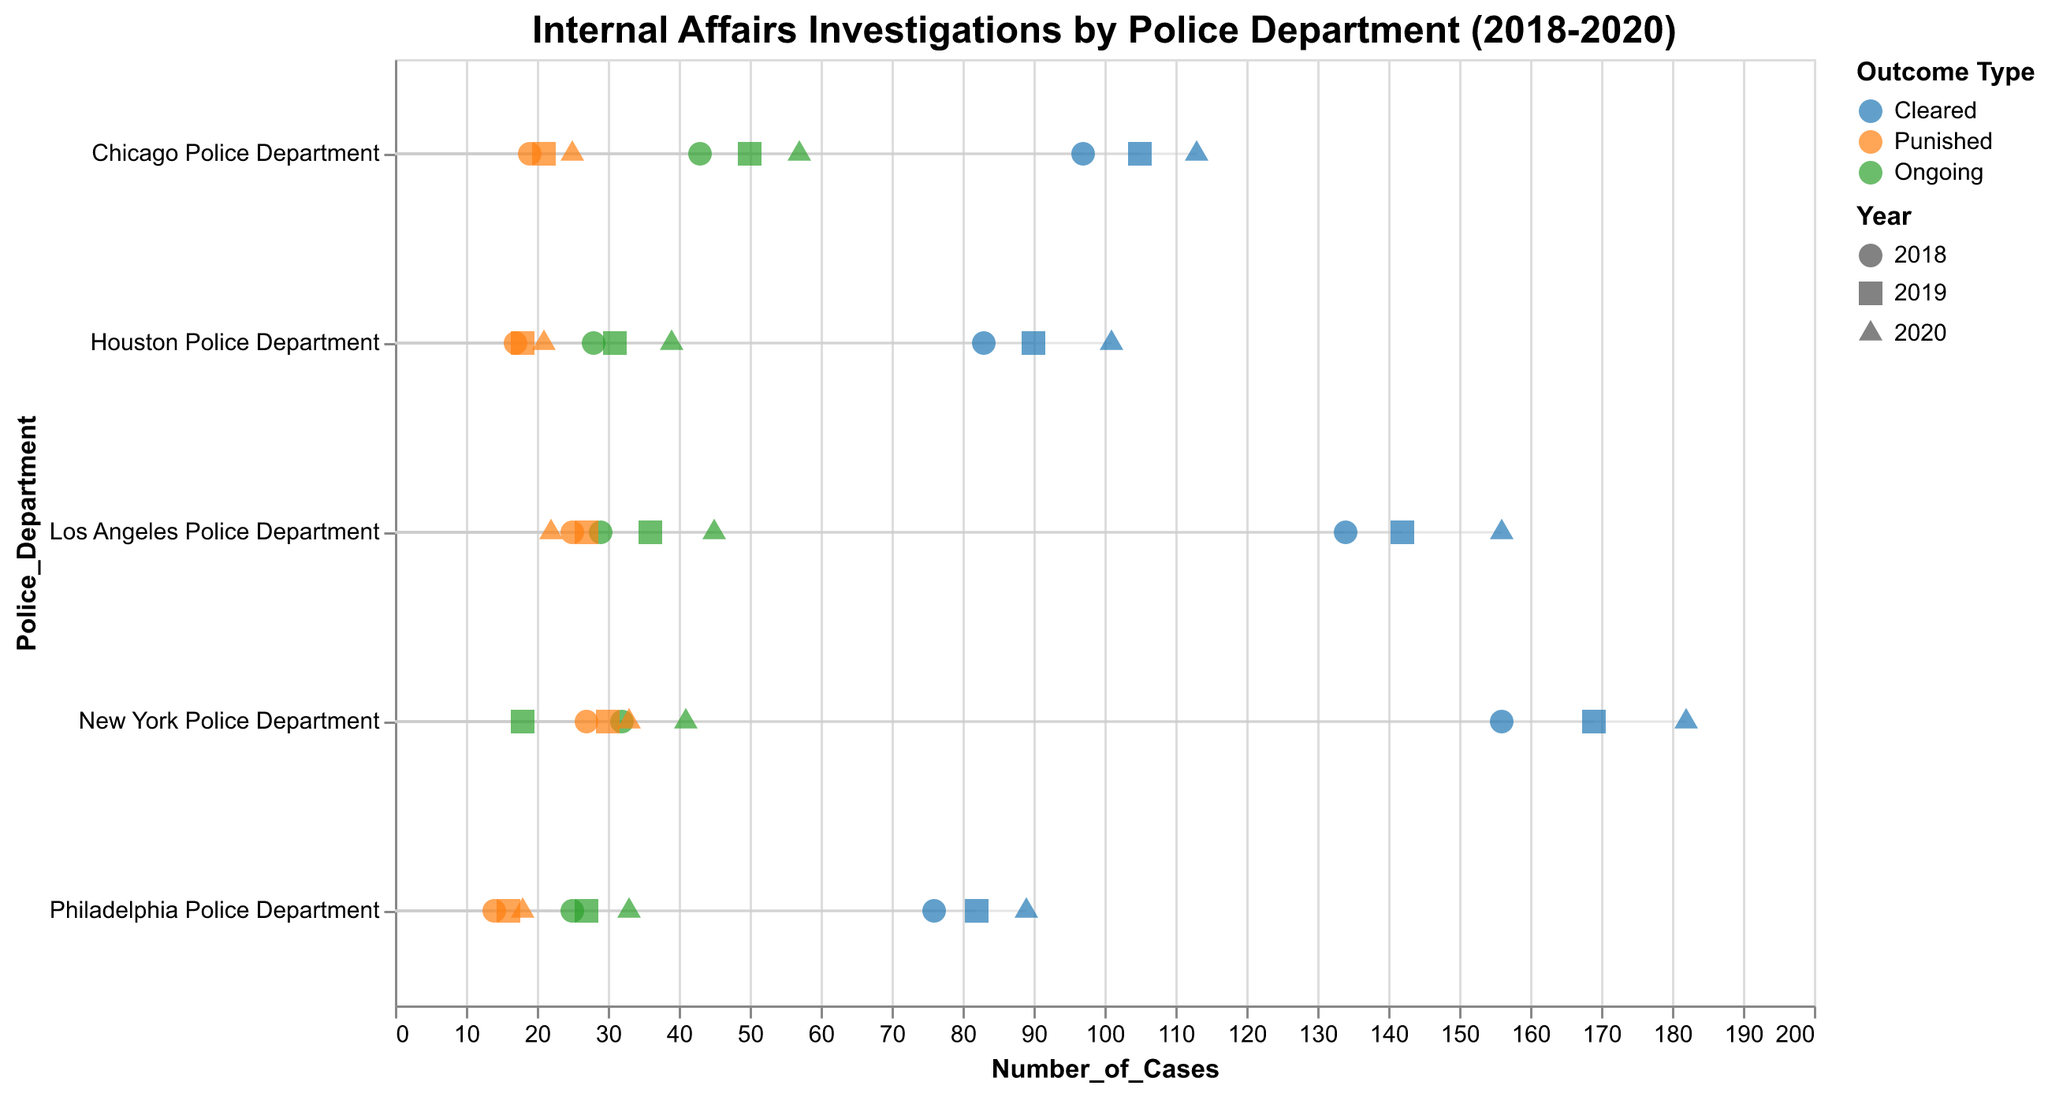Which police department had the highest number of cleared cases in 2020? The highest number of cleared cases in 2020 is represented by the blue triangle with the highest x-value in the 2020 year. The highest value of cleared cases is 182, which belongs to the New York Police Department.
Answer: New York Police Department Which police department had the lowest number of punished cases in 2018? The lowest punished cases in 2018 is represented by the orange circle with the lowest x-value in the 2018 year. The lowest value of punished cases is 14, which belongs to the Philadelphia Police Department.
Answer: Philadelphia Police Department How many ongoing cases were there in the Chicago Police Department across all three years? We need to sum the number of ongoing cases for the Chicago Police Department in 2018, 2019, and 2020. That's 43 + 50 + 57.
Answer: 150 In 2019, did the New York Police Department or the Los Angeles Police Department have more ongoing cases? Compare the number of ongoing cases for both departments in 2019, which are represented as green squares. New York has 18, whereas Los Angeles has 36.
Answer: Los Angeles Police Department Which outcome type had the largest variation in the number of cases for the New York Police Department between 2018 and 2020? Calculate the range (max - min) of each outcome type. Cleared: 182-156=26, Punished: 33-27=6, Ongoing: 41-18=23. The largest variation comes from the "Cleared" outcome.
Answer: Cleared 